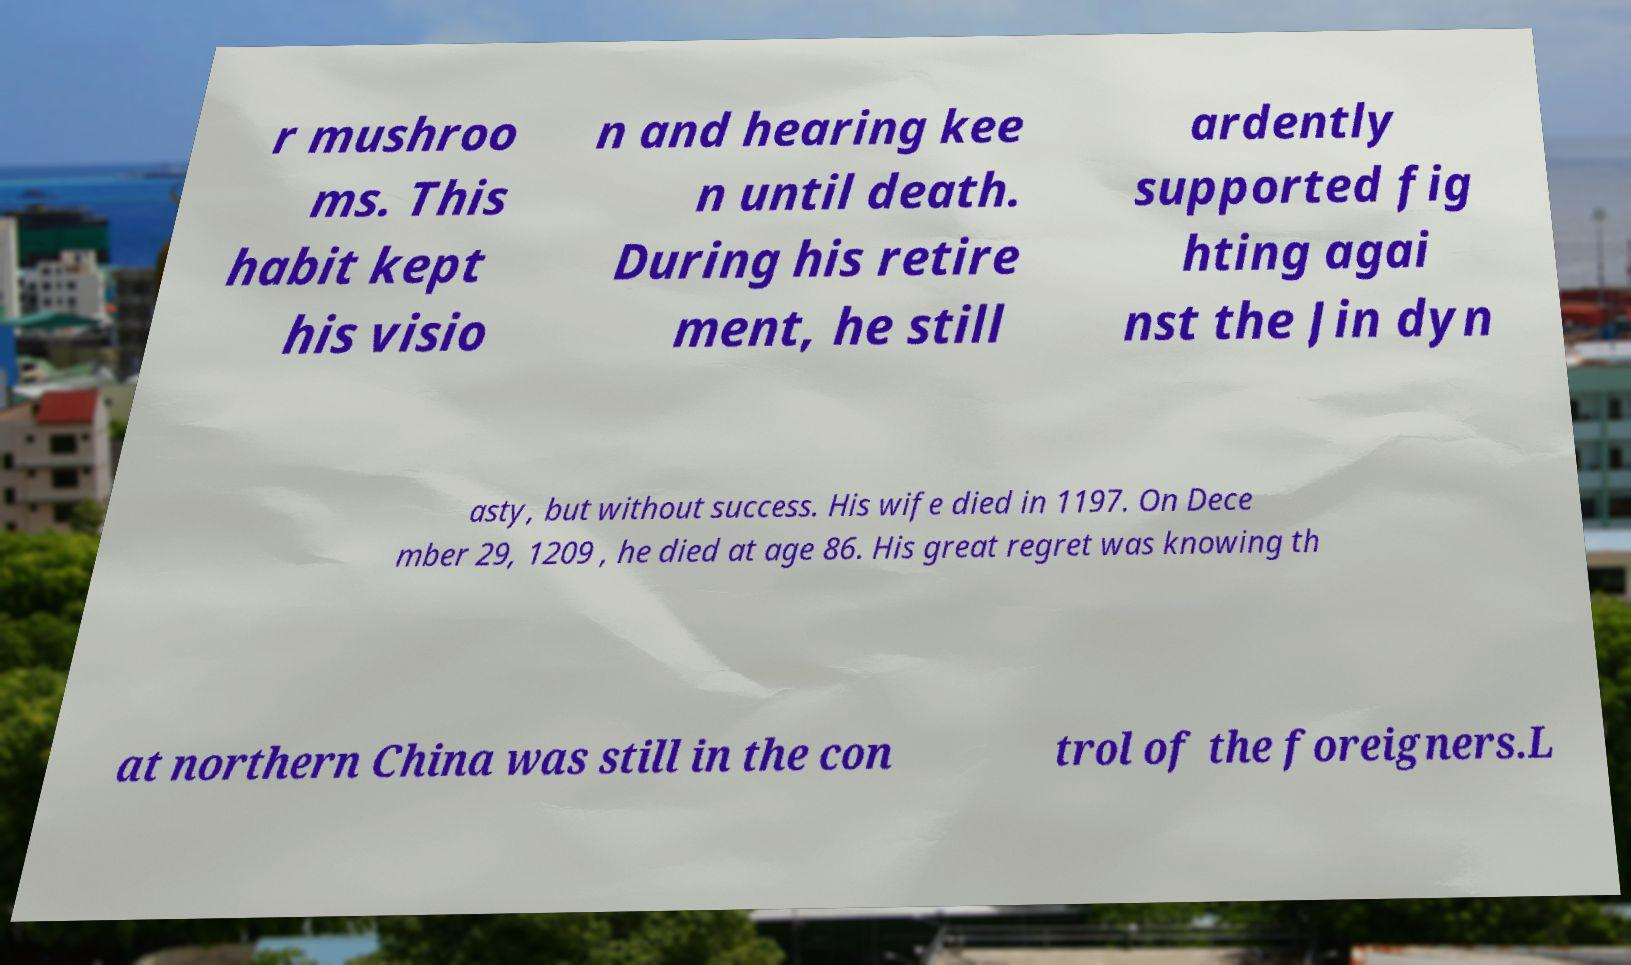Please identify and transcribe the text found in this image. r mushroo ms. This habit kept his visio n and hearing kee n until death. During his retire ment, he still ardently supported fig hting agai nst the Jin dyn asty, but without success. His wife died in 1197. On Dece mber 29, 1209 , he died at age 86. His great regret was knowing th at northern China was still in the con trol of the foreigners.L 